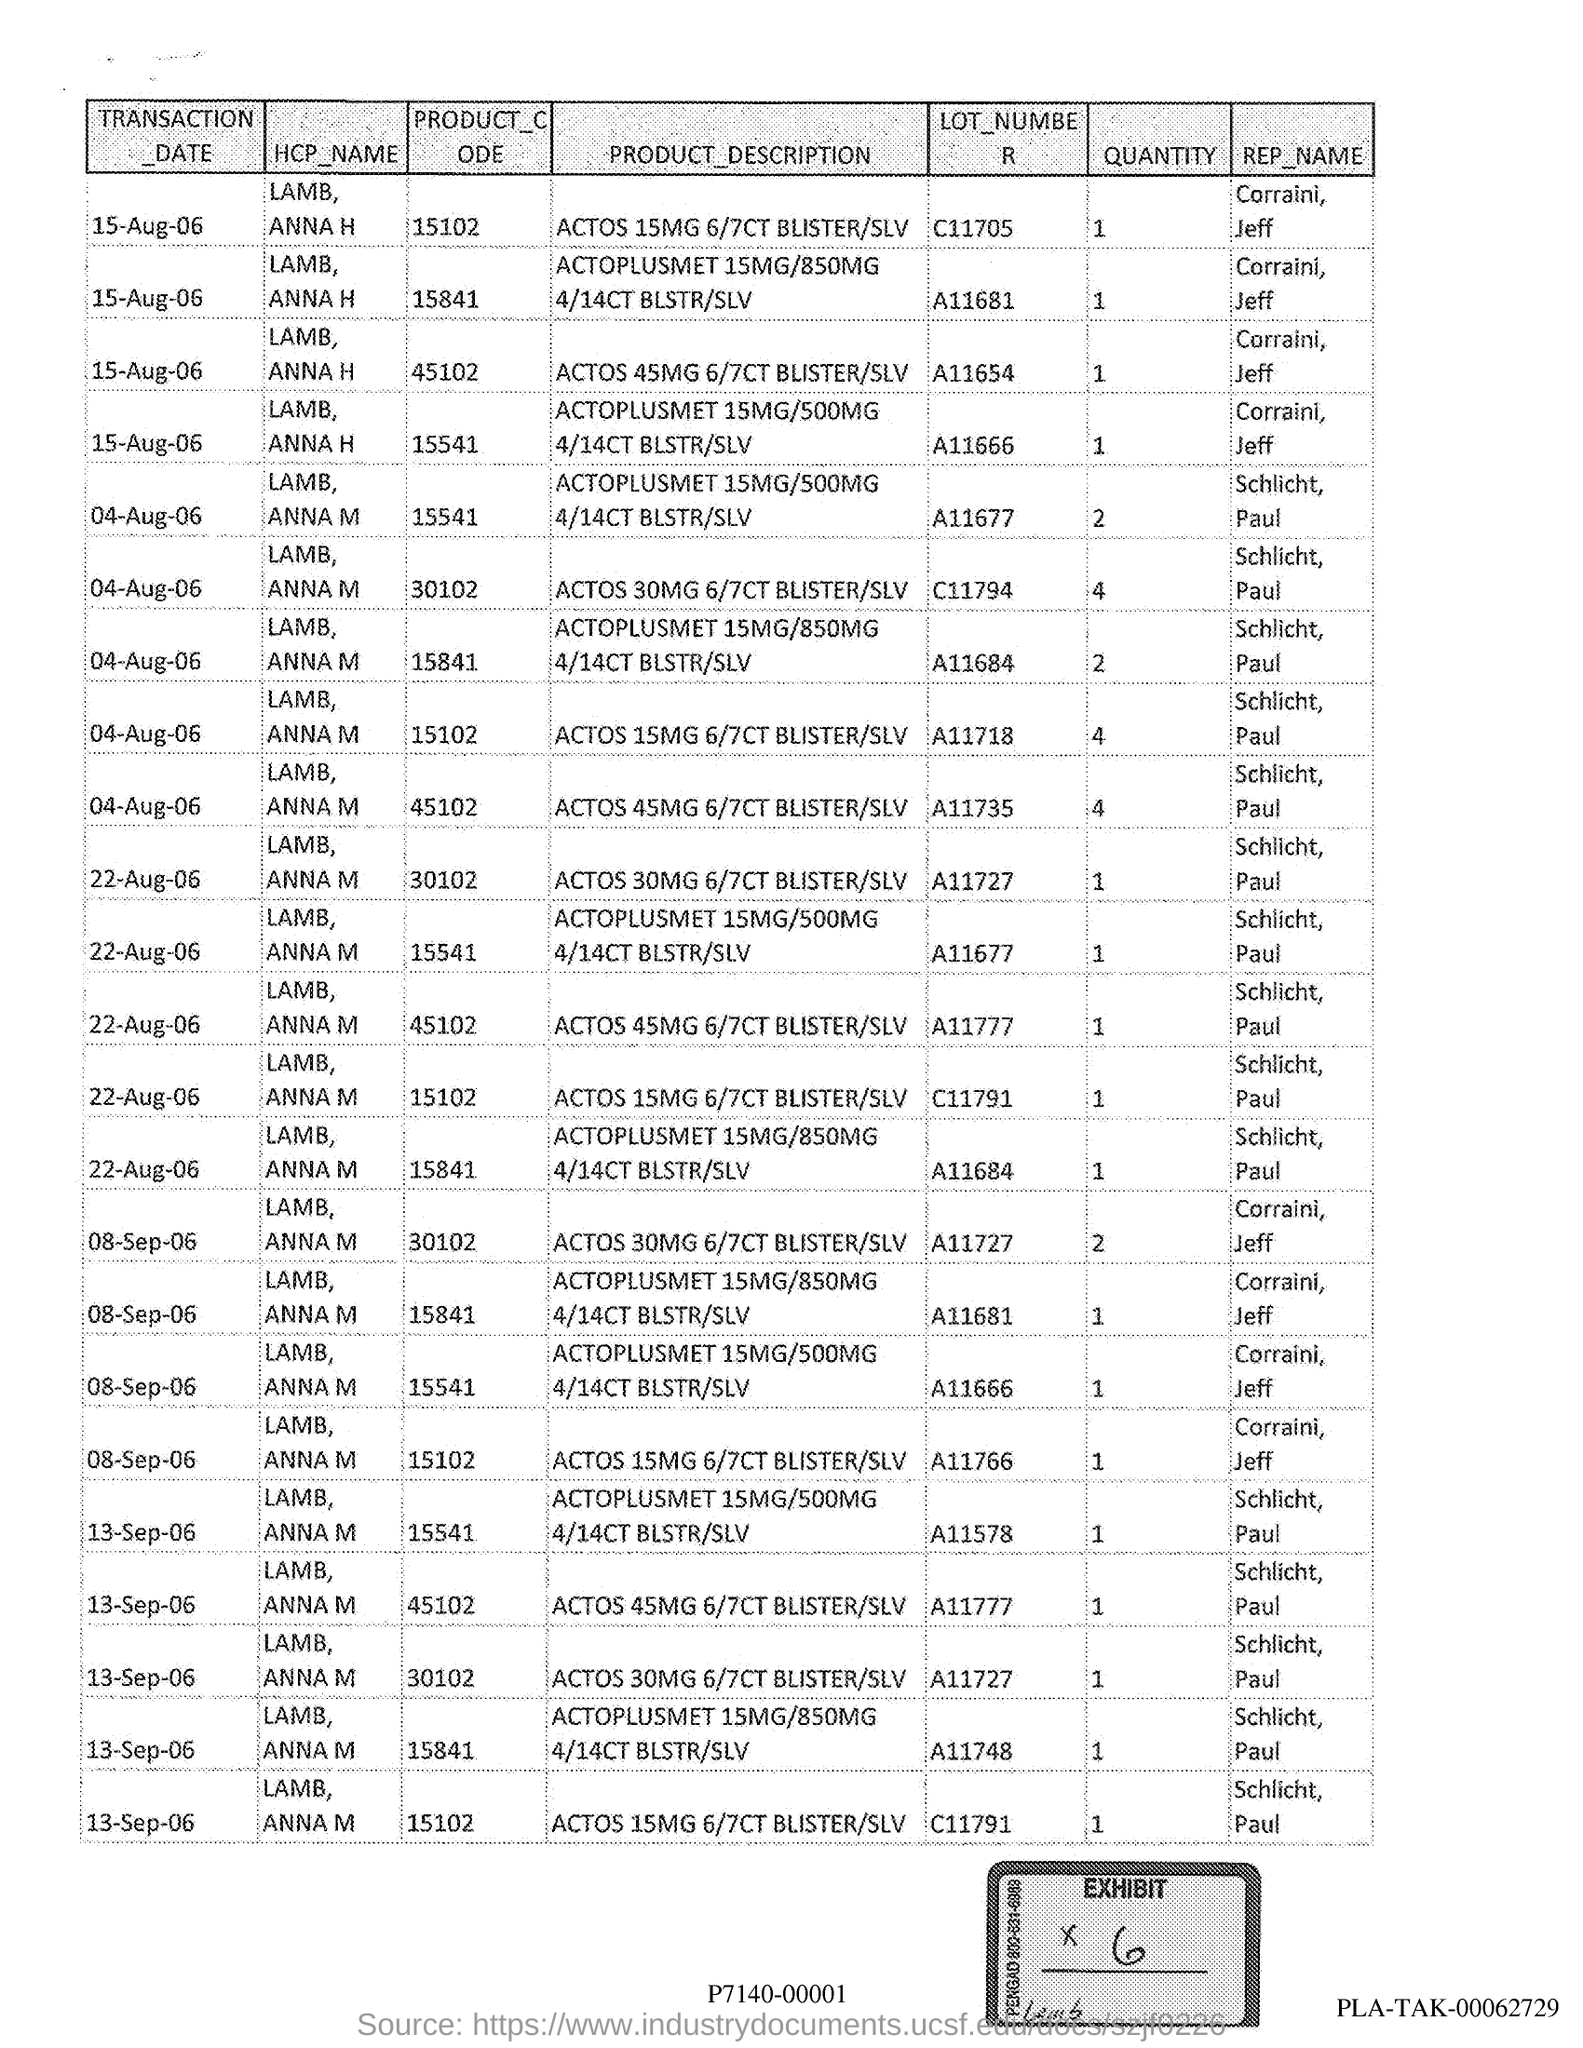Quantity of the product code 15102
Your response must be concise. 1. 